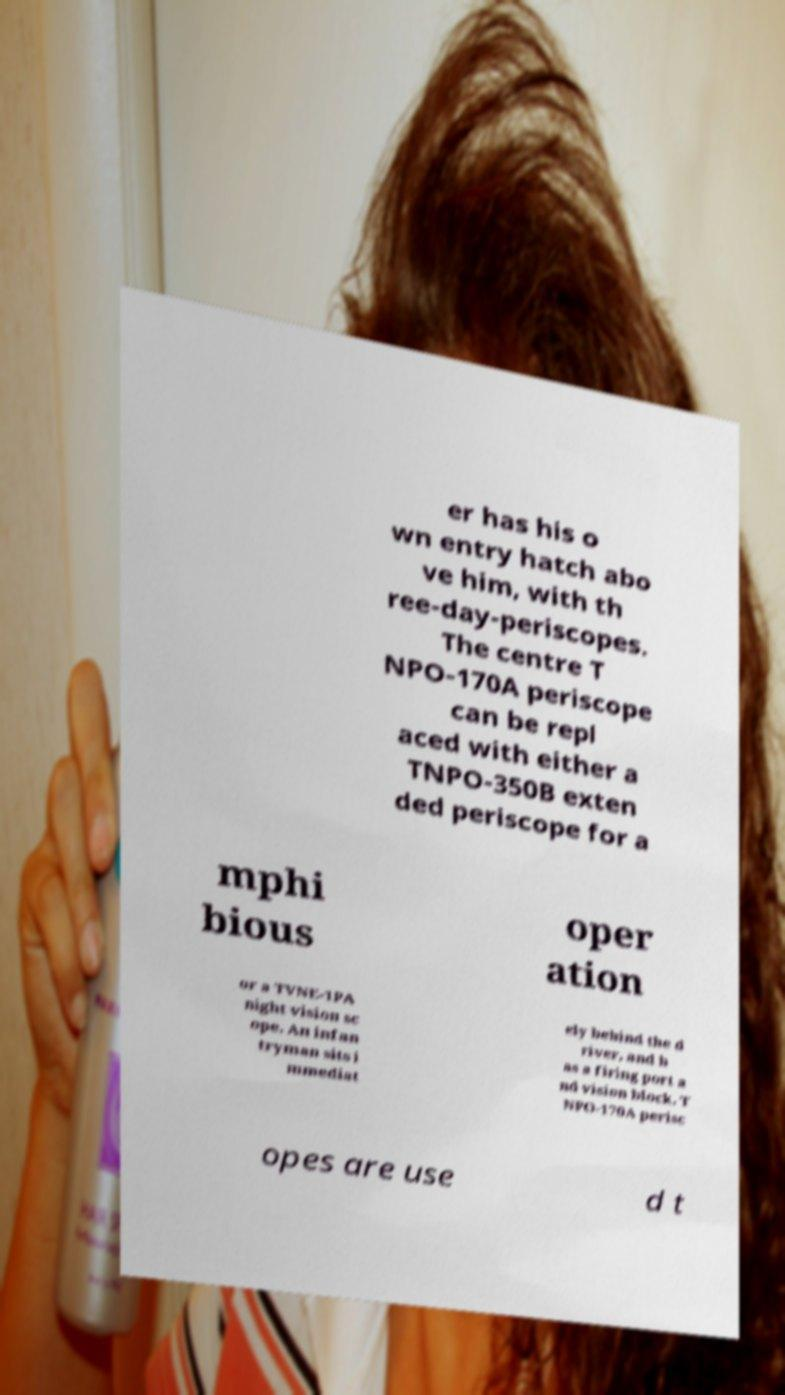Can you read and provide the text displayed in the image?This photo seems to have some interesting text. Can you extract and type it out for me? er has his o wn entry hatch abo ve him, with th ree-day-periscopes. The centre T NPO-170A periscope can be repl aced with either a TNPO-350B exten ded periscope for a mphi bious oper ation or a TVNE-1PA night vision sc ope. An infan tryman sits i mmediat ely behind the d river, and h as a firing port a nd vision block. T NPO-170A perisc opes are use d t 